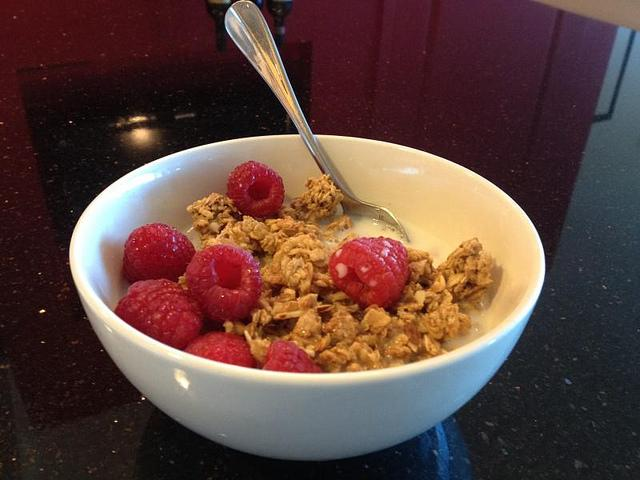Based on the reflections where is this bowl of cereal placed?

Choices:
A) kitchen
B) cafe
C) living room
D) office kitchen 